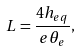<formula> <loc_0><loc_0><loc_500><loc_500>L = \frac { 4 h _ { e q } } { e \theta _ { e } } ,</formula> 